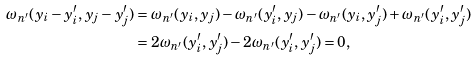<formula> <loc_0><loc_0><loc_500><loc_500>\omega _ { n ^ { \prime } } ( y _ { i } - y _ { i } ^ { \prime } , y _ { j } - y _ { j } ^ { \prime } ) & = \omega _ { n ^ { \prime } } ( y _ { i } , y _ { j } ) - \omega _ { n ^ { \prime } } ( y _ { i } ^ { \prime } , y _ { j } ) - \omega _ { n ^ { \prime } } ( y _ { i } , y _ { j } ^ { \prime } ) + \omega _ { n ^ { \prime } } ( y _ { i } ^ { \prime } , y _ { j } ^ { \prime } ) \\ & = 2 \omega _ { n ^ { \prime } } ( y _ { i } ^ { \prime } , y _ { j } ^ { \prime } ) - 2 \omega _ { n ^ { \prime } } ( y _ { i } ^ { \prime } , y _ { j } ^ { \prime } ) = 0 ,</formula> 